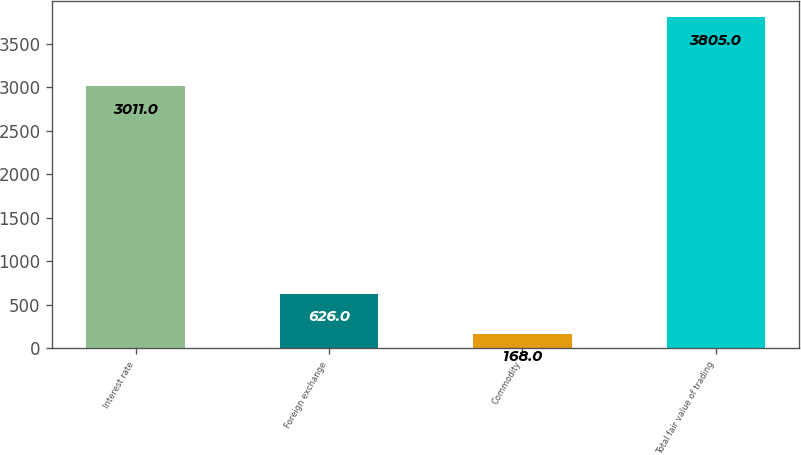Convert chart. <chart><loc_0><loc_0><loc_500><loc_500><bar_chart><fcel>Interest rate<fcel>Foreign exchange<fcel>Commodity<fcel>Total fair value of trading<nl><fcel>3011<fcel>626<fcel>168<fcel>3805<nl></chart> 